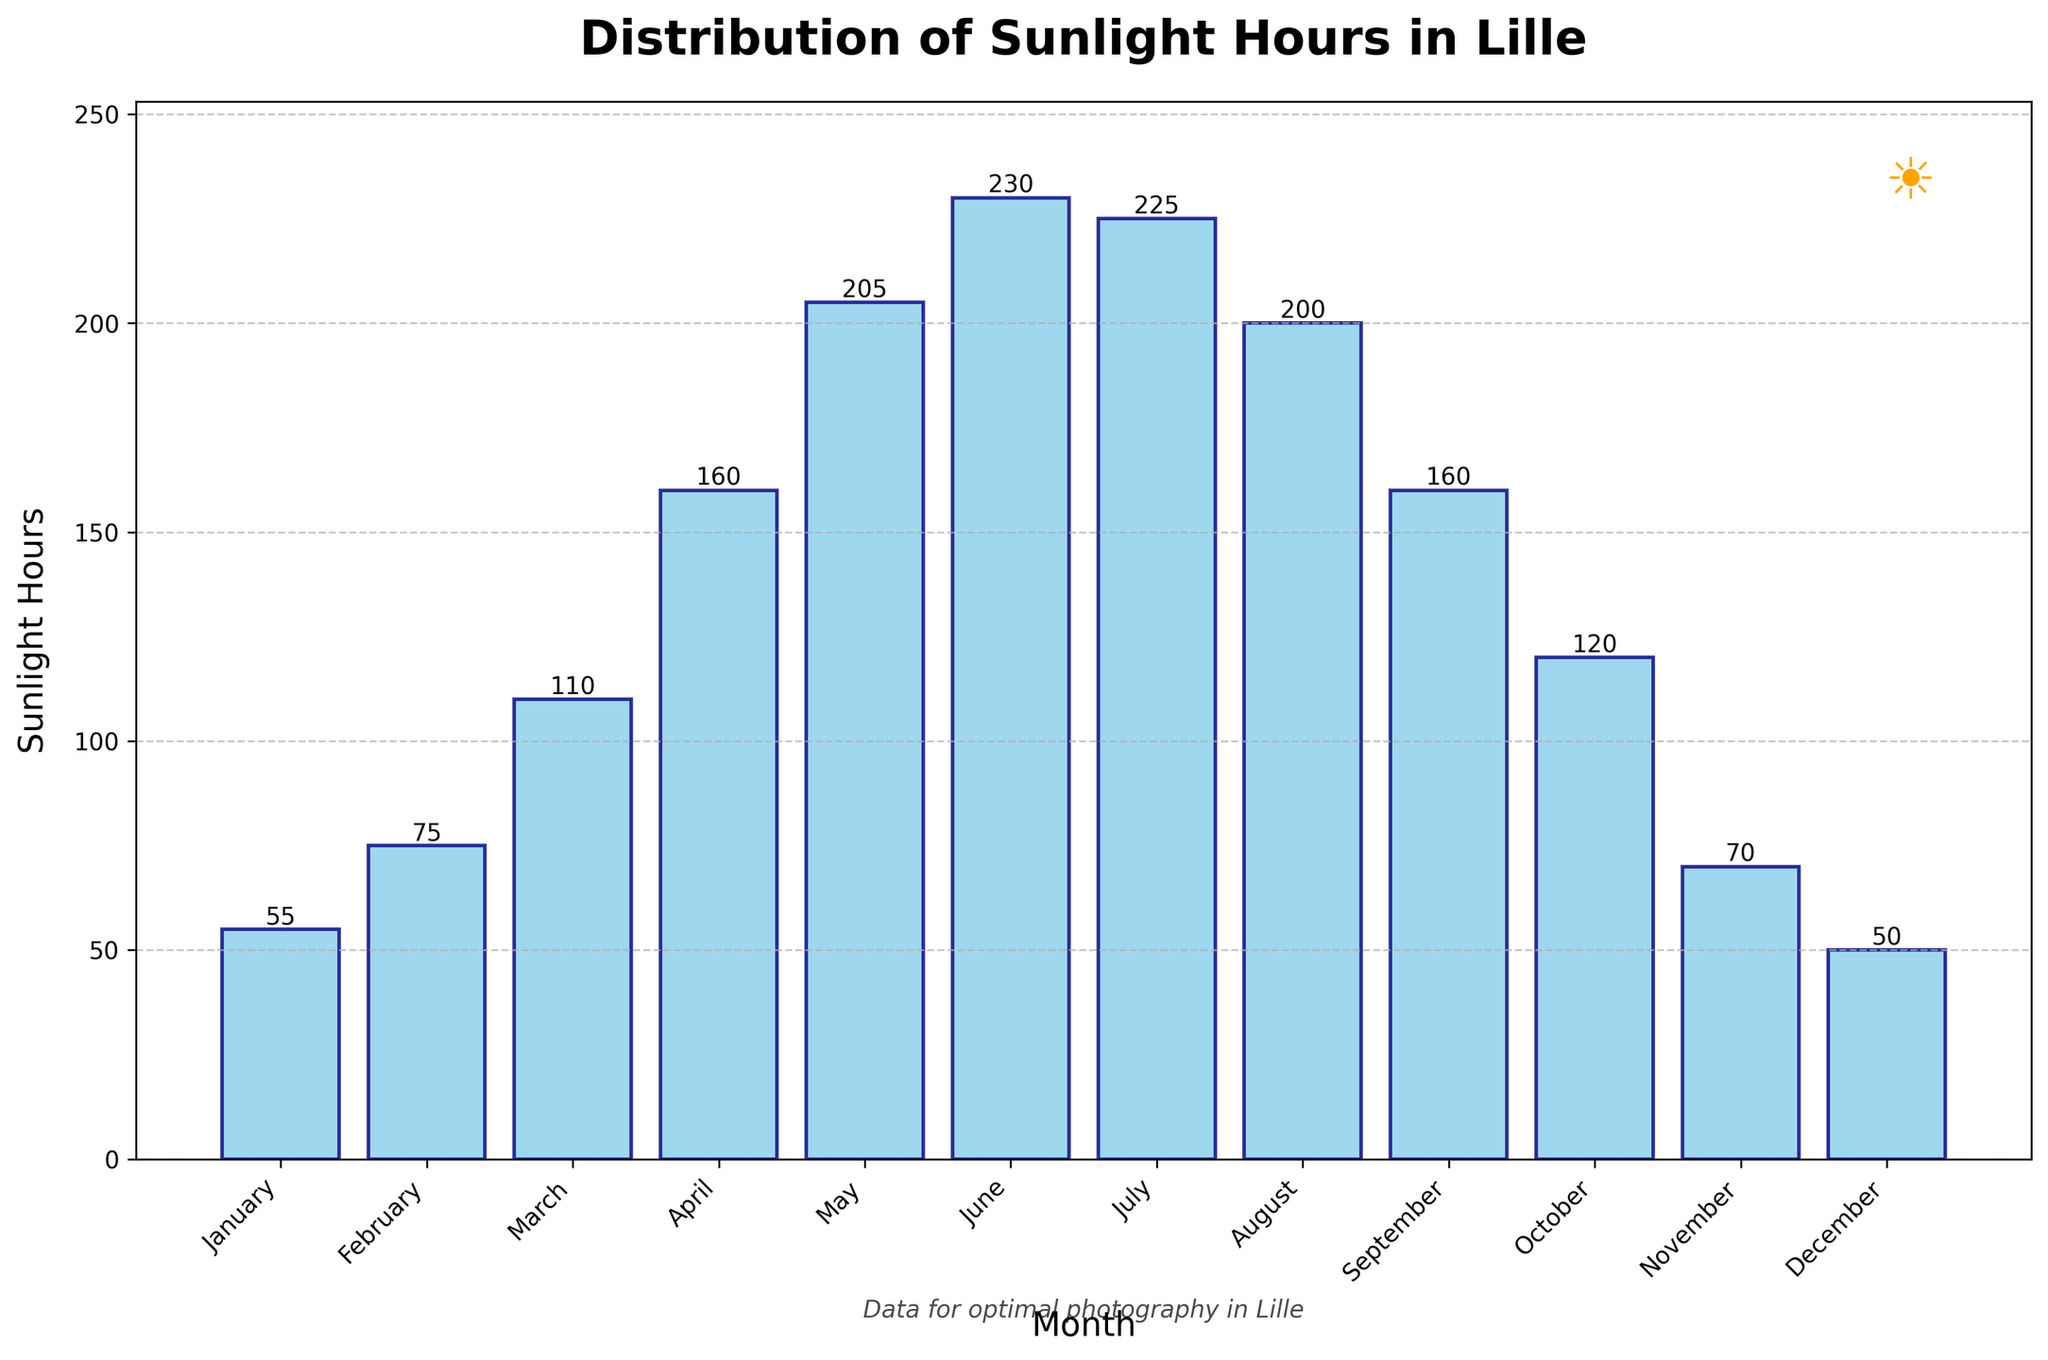What's the total number of sunlight hours in December? Look at the bar corresponding to December and read the height value.
Answer: 50 Which month has the highest number of sunlight hours? Identify the tallest bar from the plot and note the corresponding month, which is June with 230 sunlight hours.
Answer: June Compare the sunlight hours in January and July. Which month has more sunlight hours, and by how much? January has 55 sunlight hours and July has 225 sunlight hours. Subtract the January value from the July value (225 - 55).
Answer: July by 170 How many months have over 200 sunlight hours? Count the number of bars exceeding the 200-hour mark. May, June, and July exceed this mark.
Answer: 3 Calculate the average number of sunlight hours from May to August. Sum the sunlight hours from May (205), June (230), July (225), and August (200), then divide by 4: (205 + 230 + 225 + 200) / 4.
Answer: 215 Which month experiences the second lowest number of sunlight hours? Look at the second shortest bar in the plot, which is January with 55 sunlight hours.
Answer: January What's the difference in sunlight hours between the months with the most sunlight and the least sunlight? The month with the most sunlight is June (230 hours) and the least is December (50 hours). Calculate the difference: 230 - 50.
Answer: 180 During which month does Lille experience 160 sunlight hours? Locate the bar with a height of 160, which appears for both April and September.
Answer: April and September Are there any months with exactly 75 sunlight hours? Which one? Identify the bar with 75 sunlight hours, which corresponds to February.
Answer: February 